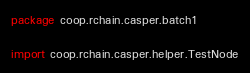Convert code to text. <code><loc_0><loc_0><loc_500><loc_500><_Scala_>package coop.rchain.casper.batch1

import coop.rchain.casper.helper.TestNode</code> 